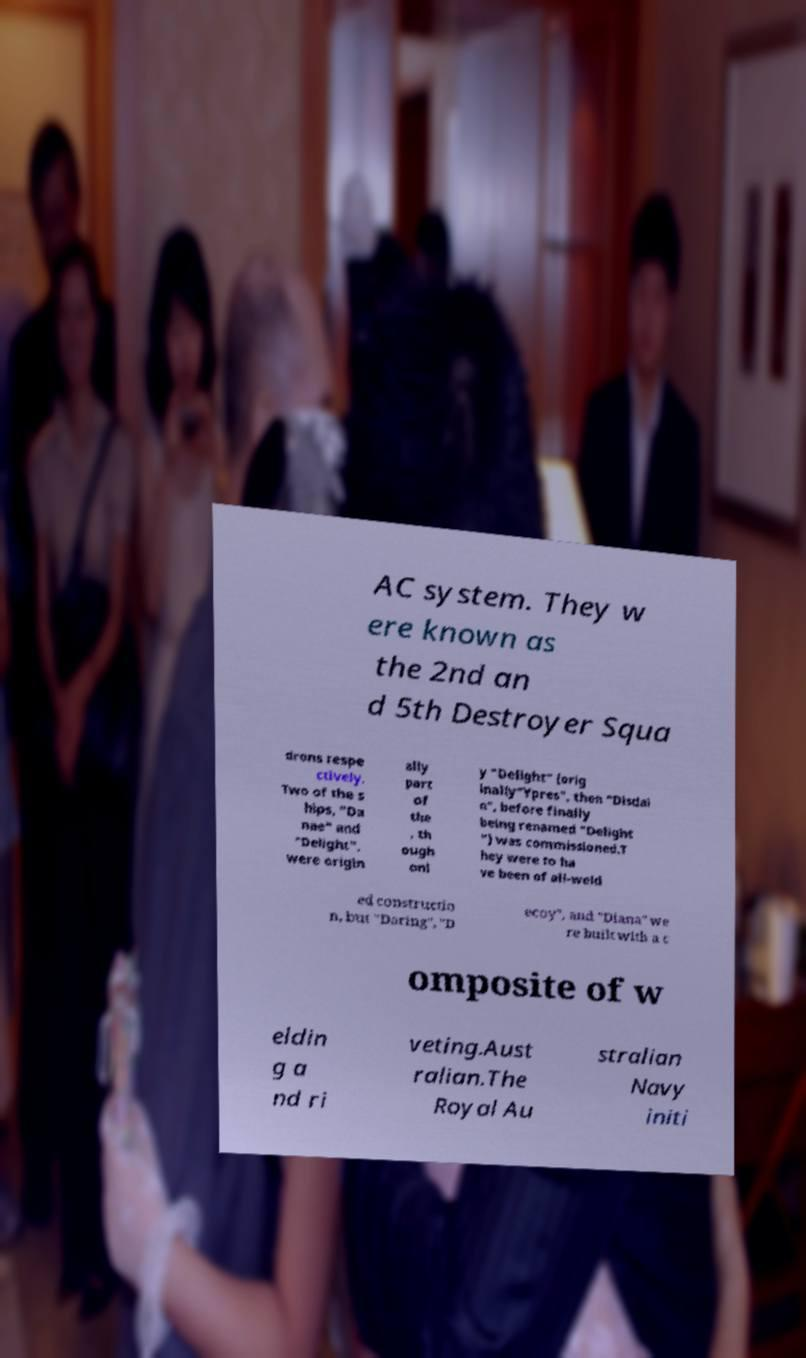What messages or text are displayed in this image? I need them in a readable, typed format. AC system. They w ere known as the 2nd an d 5th Destroyer Squa drons respe ctively. Two of the s hips, "Da nae" and "Delight", were origin ally part of the , th ough onl y "Delight" (orig inally"Ypres", then "Disdai n", before finally being renamed "Delight ") was commissioned.T hey were to ha ve been of all-weld ed constructio n, but "Daring", "D ecoy", and "Diana" we re built with a c omposite of w eldin g a nd ri veting.Aust ralian.The Royal Au stralian Navy initi 